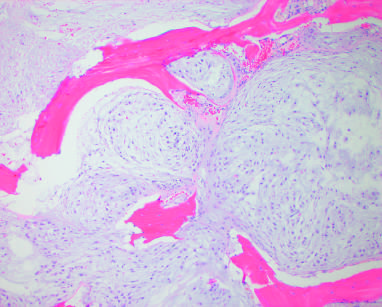what entraps native lamellar bone as a confluent mass of cartilage?
Answer the question using a single word or phrase. Conventional chondrosarcoma 